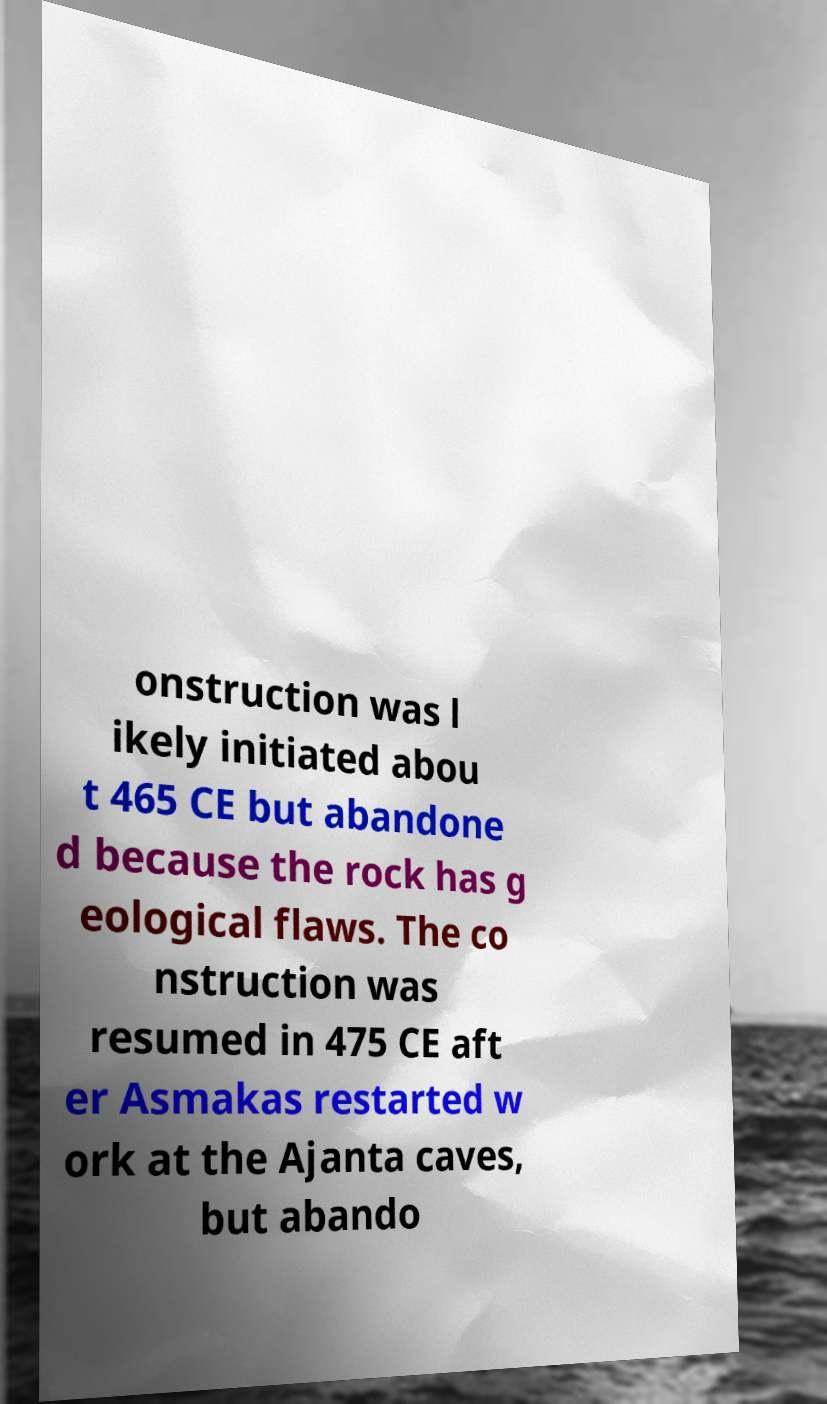For documentation purposes, I need the text within this image transcribed. Could you provide that? onstruction was l ikely initiated abou t 465 CE but abandone d because the rock has g eological flaws. The co nstruction was resumed in 475 CE aft er Asmakas restarted w ork at the Ajanta caves, but abando 